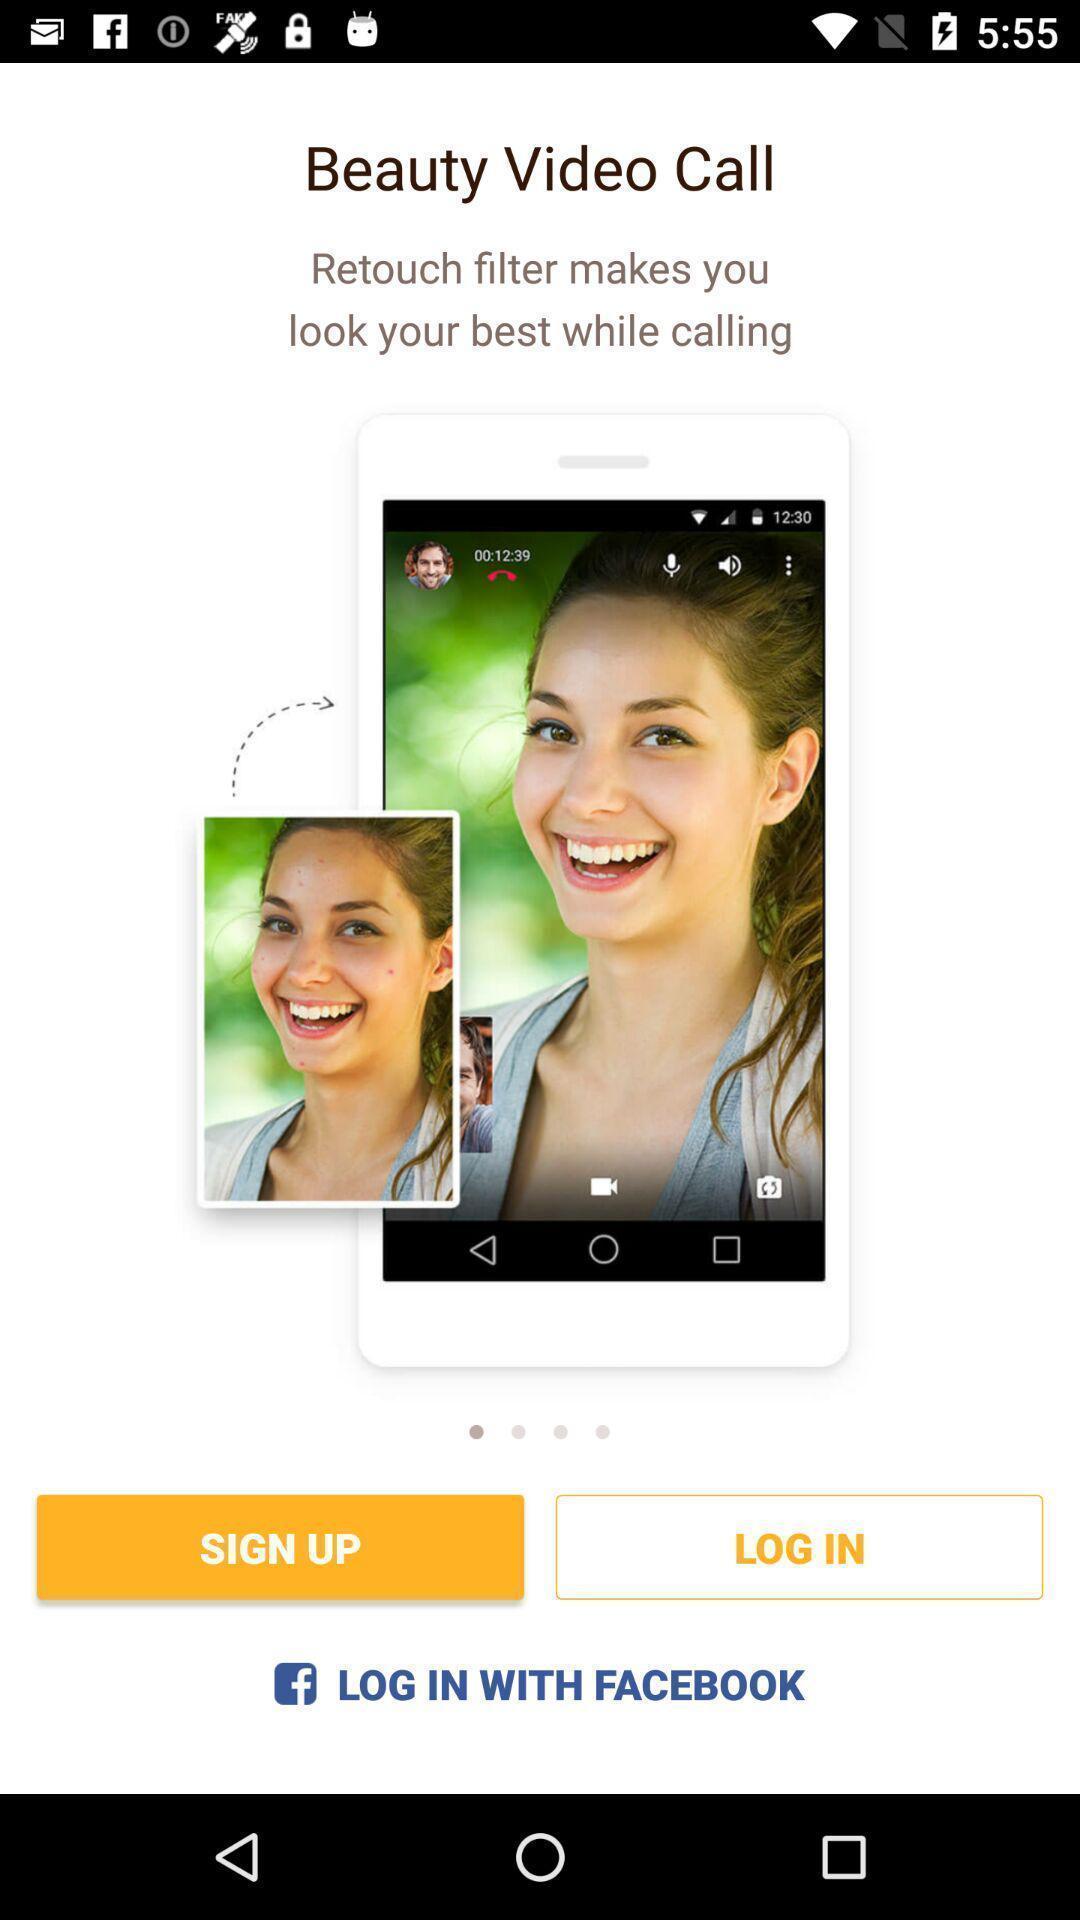Describe the visual elements of this screenshot. Sign up page. 